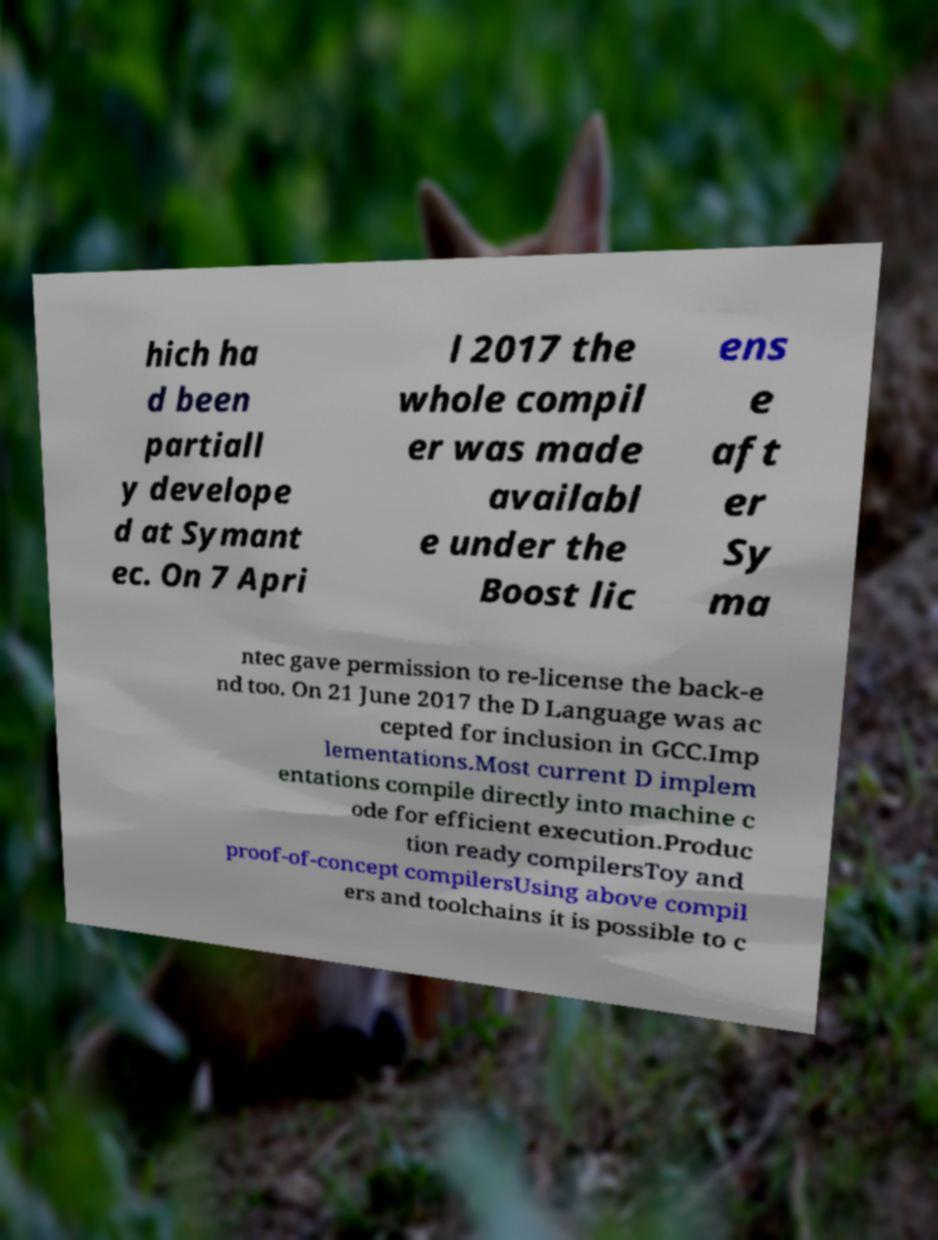What messages or text are displayed in this image? I need them in a readable, typed format. hich ha d been partiall y develope d at Symant ec. On 7 Apri l 2017 the whole compil er was made availabl e under the Boost lic ens e aft er Sy ma ntec gave permission to re-license the back-e nd too. On 21 June 2017 the D Language was ac cepted for inclusion in GCC.Imp lementations.Most current D implem entations compile directly into machine c ode for efficient execution.Produc tion ready compilersToy and proof-of-concept compilersUsing above compil ers and toolchains it is possible to c 